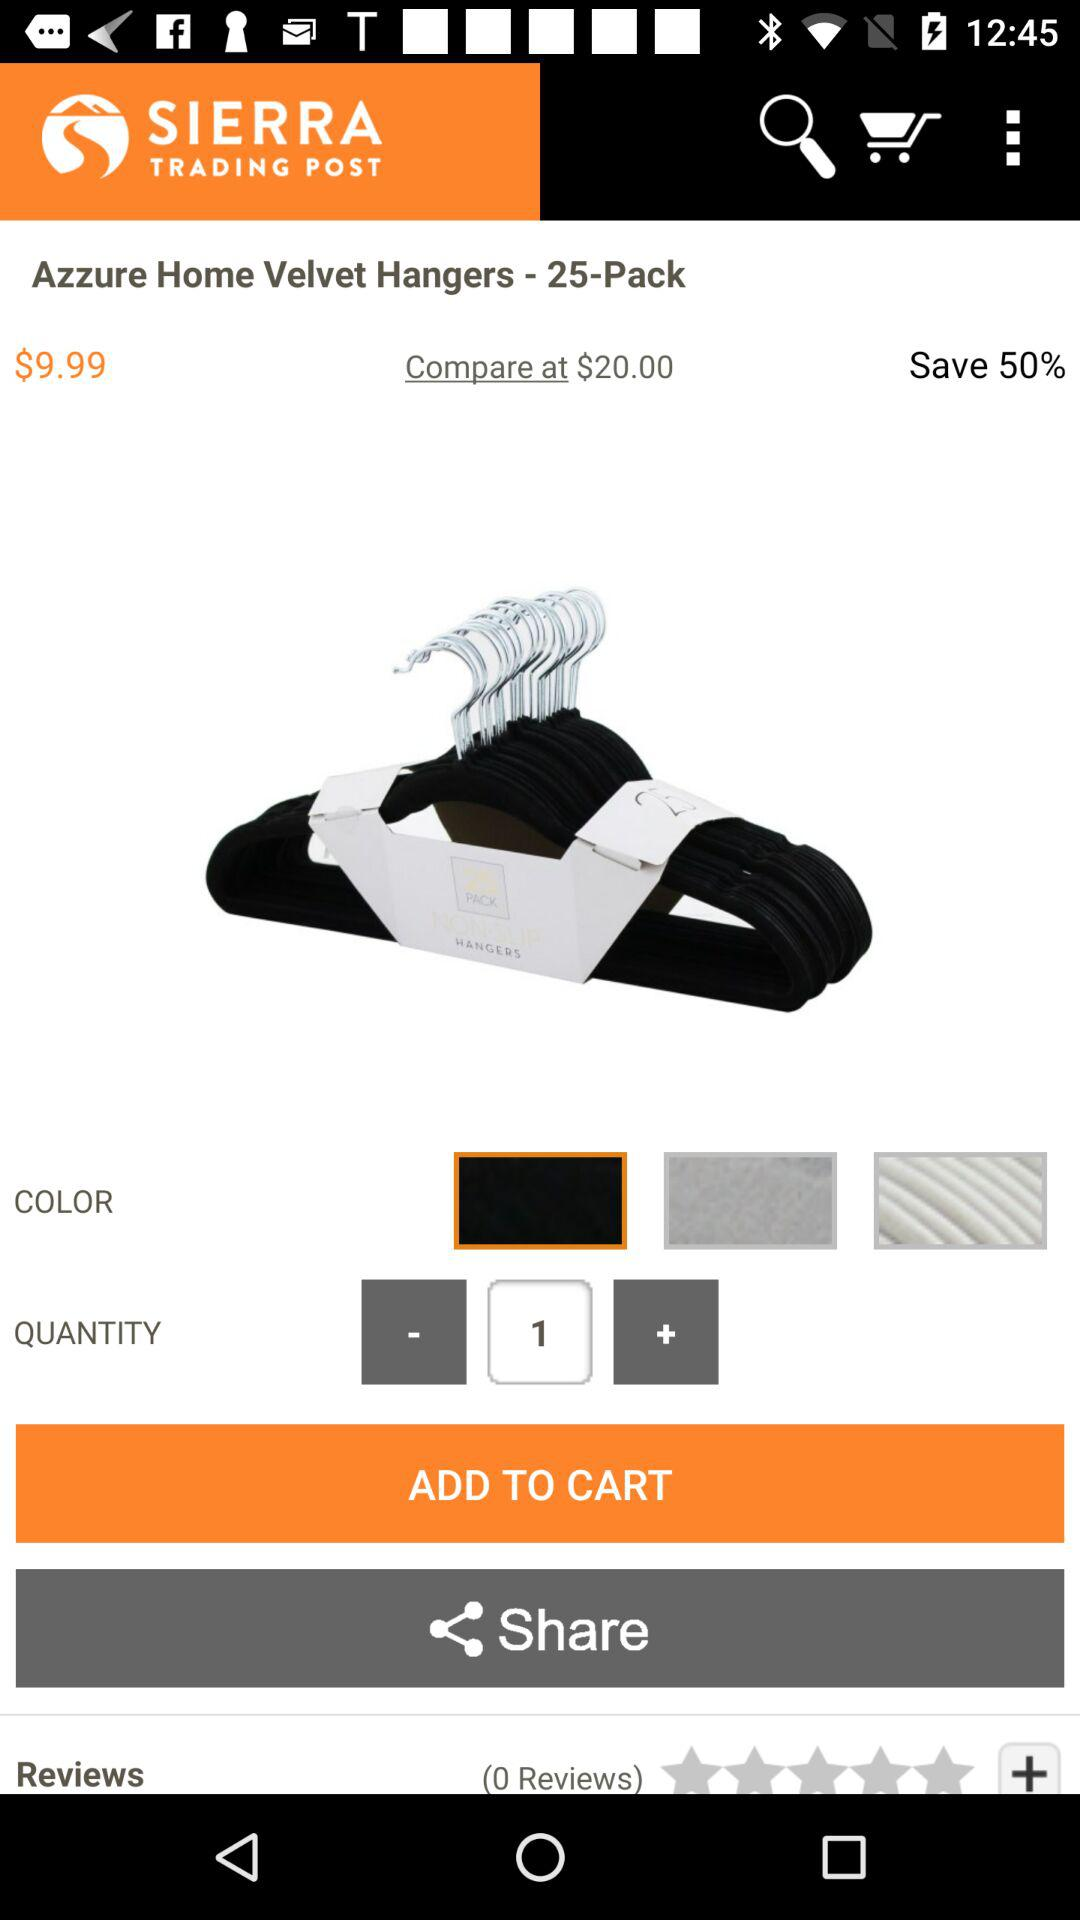How many items are in the cart?
When the provided information is insufficient, respond with <no answer>. <no answer> 